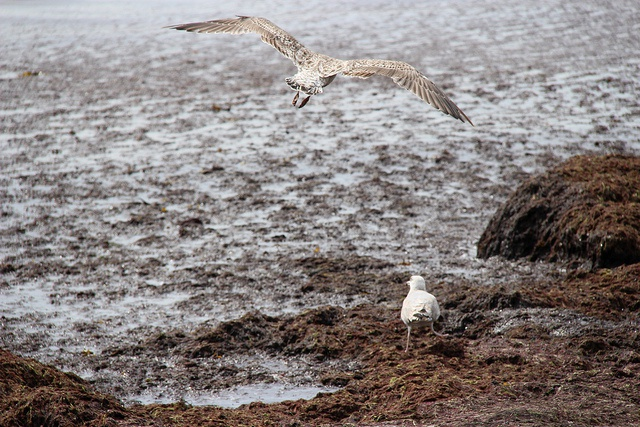Describe the objects in this image and their specific colors. I can see bird in darkgray, lightgray, and gray tones and bird in darkgray, lightgray, gray, and black tones in this image. 